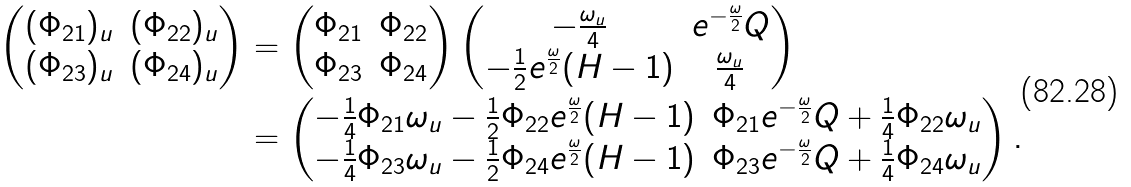Convert formula to latex. <formula><loc_0><loc_0><loc_500><loc_500>\begin{pmatrix} ( \Phi _ { 2 1 } ) _ { u } & ( \Phi _ { 2 2 } ) _ { u } \\ ( \Phi _ { 2 3 } ) _ { u } & ( \Phi _ { 2 4 } ) _ { u } \end{pmatrix} & = \begin{pmatrix} \Phi _ { 2 1 } & \Phi _ { 2 2 } \\ \Phi _ { 2 3 } & \Phi _ { 2 4 } \end{pmatrix} \begin{pmatrix} - \frac { \omega _ { u } } { 4 } & e ^ { - \frac { \omega } { 2 } } Q \\ - \frac { 1 } { 2 } e ^ { \frac { \omega } { 2 } } ( H - 1 ) & \frac { \omega _ { u } } { 4 } \end{pmatrix} \\ & = \begin{pmatrix} - \frac { 1 } { 4 } \Phi _ { 2 1 } \omega _ { u } - \frac { 1 } { 2 } \Phi _ { 2 2 } e ^ { \frac { \omega } { 2 } } ( H - 1 ) & \Phi _ { 2 1 } e ^ { - \frac { \omega } { 2 } } Q + \frac { 1 } { 4 } \Phi _ { 2 2 } \omega _ { u } \\ - \frac { 1 } { 4 } \Phi _ { 2 3 } \omega _ { u } - \frac { 1 } { 2 } \Phi _ { 2 4 } e ^ { \frac { \omega } { 2 } } ( H - 1 ) & \Phi _ { 2 3 } e ^ { - \frac { \omega } { 2 } } Q + \frac { 1 } { 4 } \Phi _ { 2 4 } \omega _ { u } \end{pmatrix} .</formula> 